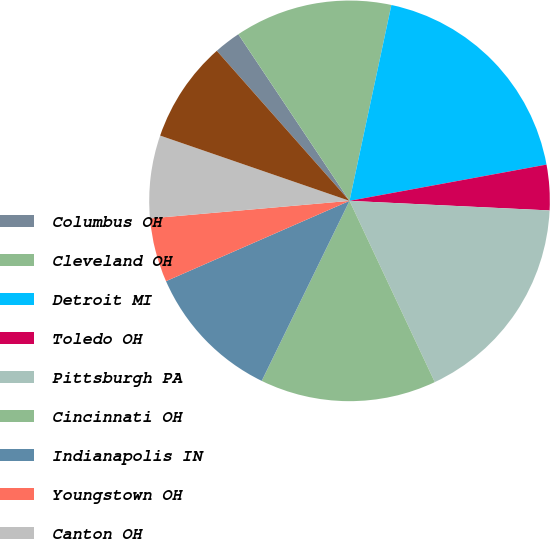Convert chart. <chart><loc_0><loc_0><loc_500><loc_500><pie_chart><fcel>Columbus OH<fcel>Cleveland OH<fcel>Detroit MI<fcel>Toledo OH<fcel>Pittsburgh PA<fcel>Cincinnati OH<fcel>Indianapolis IN<fcel>Youngstown OH<fcel>Canton OH<fcel>Grand Rapids MI<nl><fcel>2.16%<fcel>12.72%<fcel>18.75%<fcel>3.66%<fcel>17.24%<fcel>14.22%<fcel>11.21%<fcel>5.17%<fcel>6.68%<fcel>8.19%<nl></chart> 